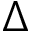Convert formula to latex. <formula><loc_0><loc_0><loc_500><loc_500>\Delta</formula> 